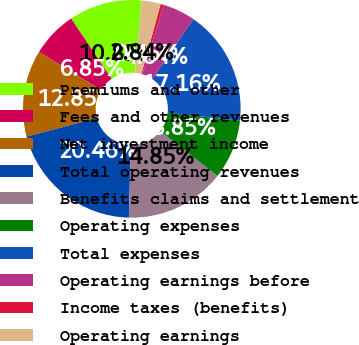Convert chart. <chart><loc_0><loc_0><loc_500><loc_500><pie_chart><fcel>Premiums and other<fcel>Fees and other revenues<fcel>Net investment income<fcel>Total operating revenues<fcel>Benefits claims and settlement<fcel>Operating expenses<fcel>Total expenses<fcel>Operating earnings before<fcel>Income taxes (benefits)<fcel>Operating earnings<nl><fcel>10.85%<fcel>6.85%<fcel>12.85%<fcel>20.46%<fcel>14.85%<fcel>8.85%<fcel>17.16%<fcel>4.84%<fcel>0.45%<fcel>2.84%<nl></chart> 